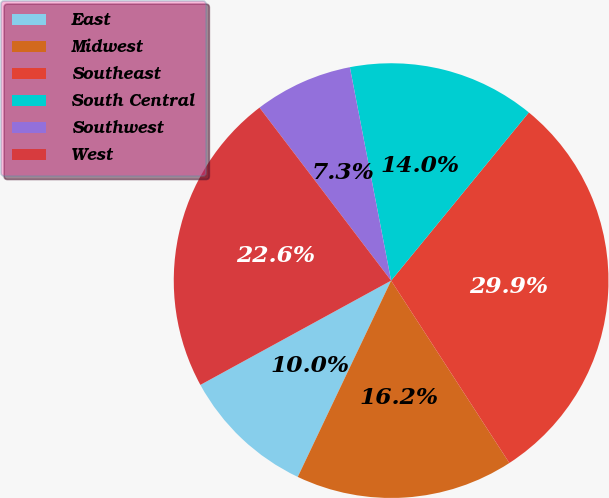Convert chart. <chart><loc_0><loc_0><loc_500><loc_500><pie_chart><fcel>East<fcel>Midwest<fcel>Southeast<fcel>South Central<fcel>Southwest<fcel>West<nl><fcel>9.97%<fcel>16.22%<fcel>29.92%<fcel>13.96%<fcel>7.31%<fcel>22.61%<nl></chart> 